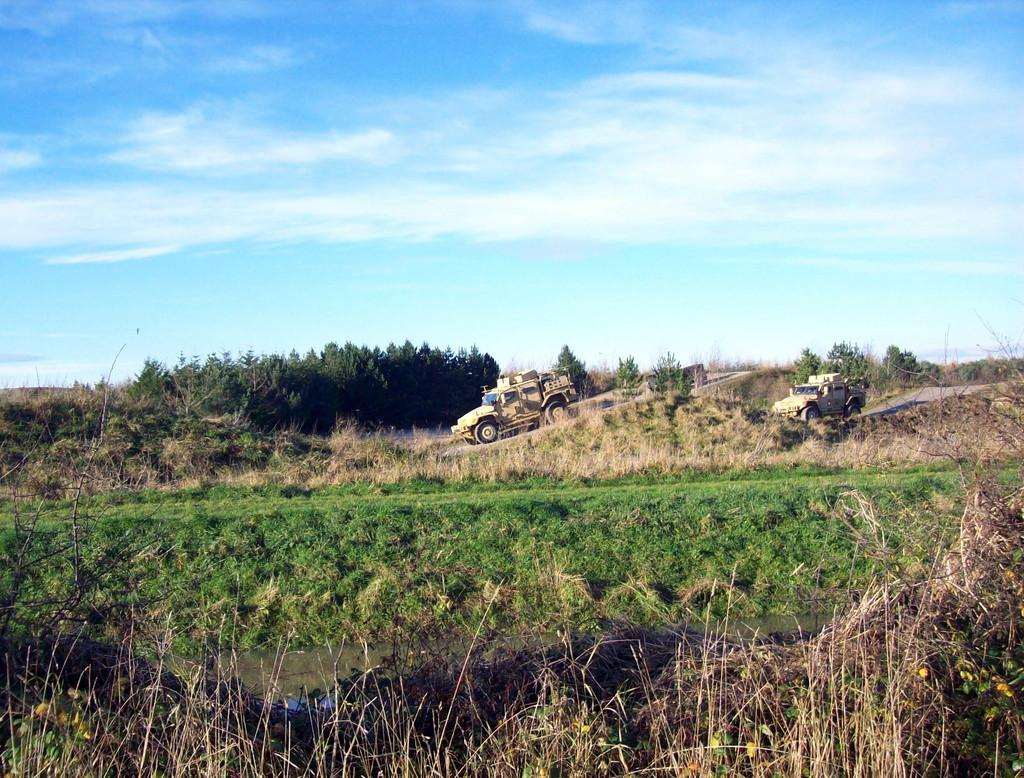What is happening on the road in the image? There are vehicles on the road in the image. What can be seen in the surroundings of the road? Trees and grass are visible around the road. What instrument is the person reading an error message from in the image? There is no person or instrument visible in the image; it only shows vehicles on the road with trees and grass in the surroundings. 